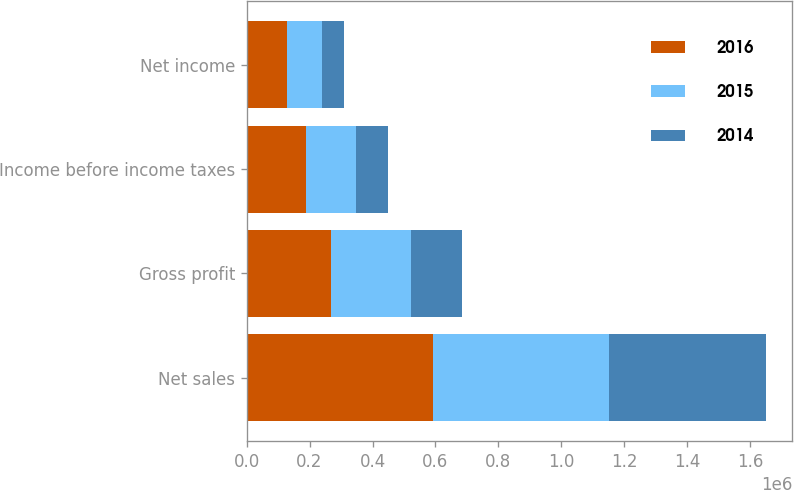Convert chart to OTSL. <chart><loc_0><loc_0><loc_500><loc_500><stacked_bar_chart><ecel><fcel>Net sales<fcel>Gross profit<fcel>Income before income taxes<fcel>Net income<nl><fcel>2016<fcel>590980<fcel>267241<fcel>189016<fcel>126872<nl><fcel>2015<fcel>560376<fcel>253569<fcel>157501<fcel>111491<nl><fcel>2014<fcel>499394<fcel>164063<fcel>101983<fcel>71466<nl></chart> 